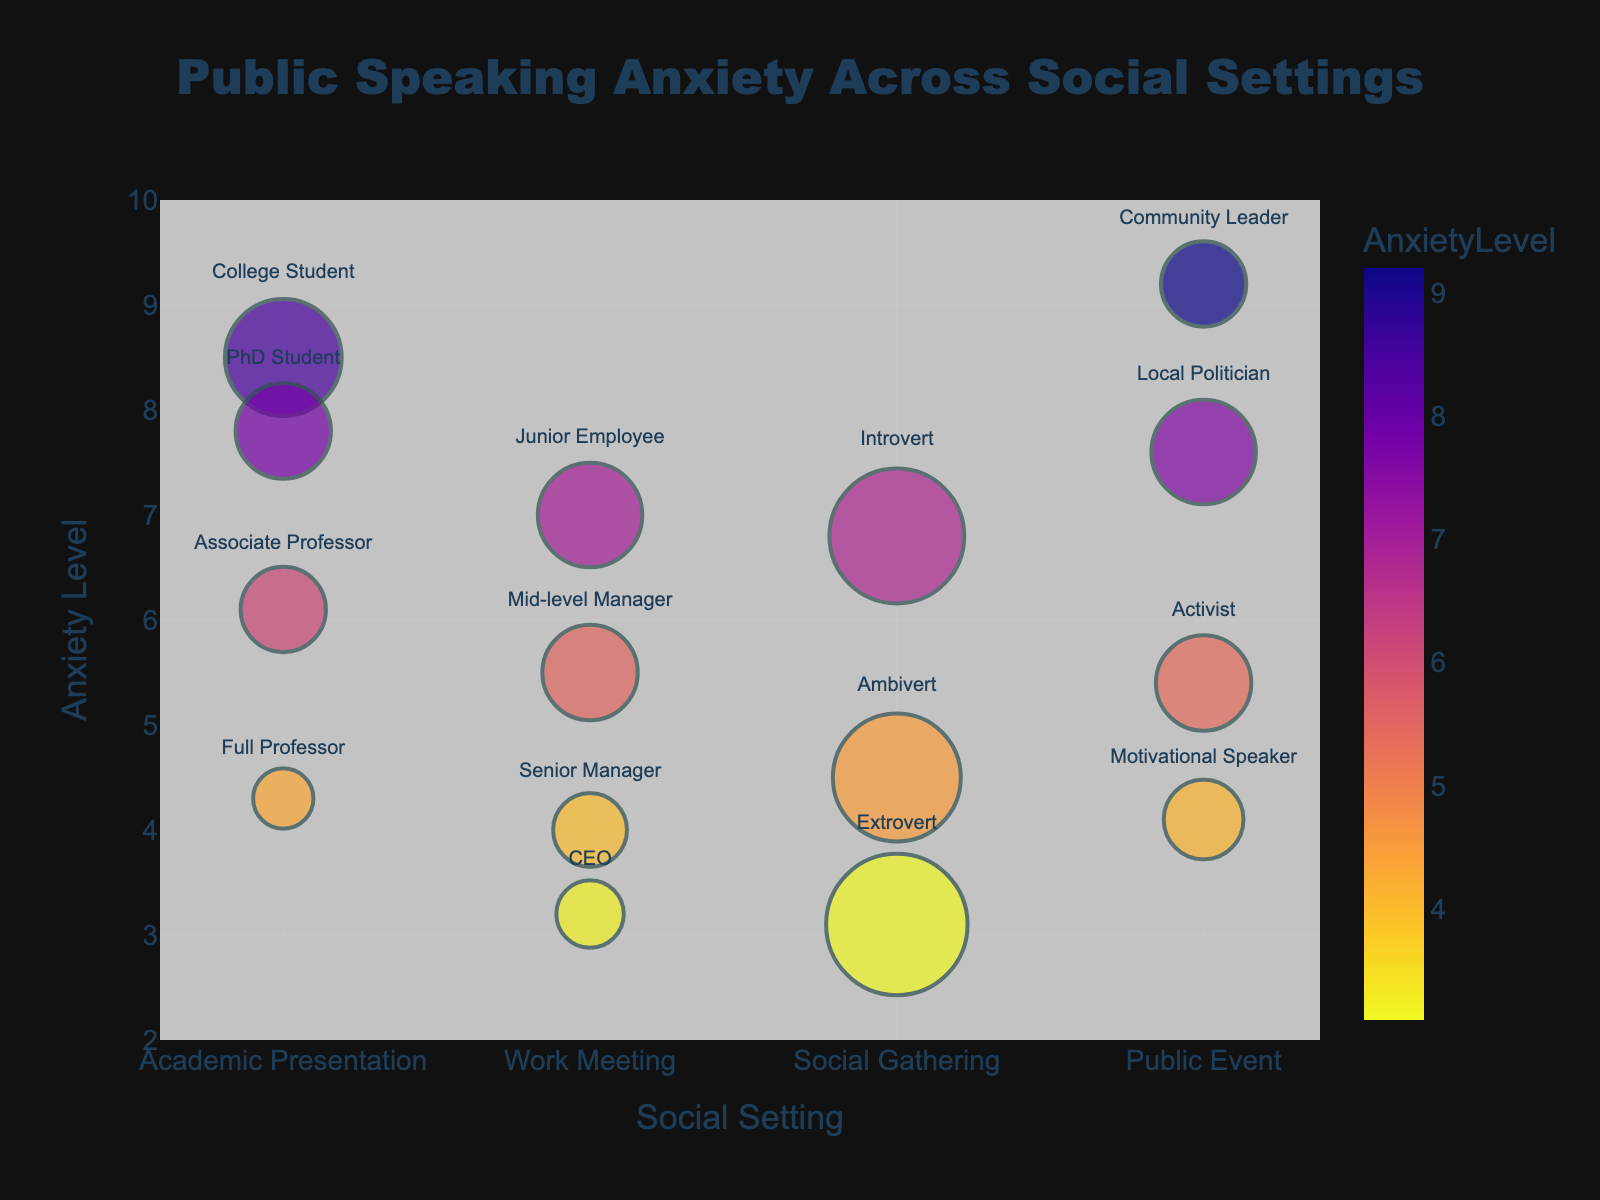What's the title of the chart? The title of a chart is usually located at the top center of the figure. It provides a quick overview of what the chart represents. In this case, the title is stated to be "Public Speaking Anxiety Across Social Settings".
Answer: Public Speaking Anxiety Across Social Settings Which social setting has the highest average anxiety level? To find the social setting with the highest average anxiety level, look at the y-axis values that are highest for each social setting. The Academic Presentations have a highest value of 8.5 (College Student), while Work Meetings highest is 7.0 (Junior Employee), Social Gatherings is 6.8 (Introvert), and Public Events is 9.2 (Community Leader).
Answer: Public Event How many social settings are represented in the chart? Count the distinct categories along the x-axis of the chart, representing different social settings. These are "Academic Presentation", "Work Meeting", "Social Gathering", and "Public Event". There are four categories.
Answer: 4 Which speaker identity has the lowest anxiety level in the chart? To find the speaker with the lowest anxiety level, look at the data points with the smallest y-axis values. The data point with the lowest y-axis value represents "CEO" in Work Meeting with an anxiety level of 3.2.
Answer: CEO Compare the anxiety levels of Introverts and Extroverts in social gatherings. Which group shows higher anxiety and by how much? Look at the data points for Introverts and Extroverts within "Social Gathering". The Introvert's anxiety level is 6.8, and the Extrovert's anxiety level is 3.1. To find the difference, subtract 3.1 from 6.8, which gives 3.7. So, Introverts show higher anxiety by 3.7 points.
Answer: Introverts, 3.7 What is the total frequency of speakers in the "Academic Presentations" setting? To determine the total frequency for "Academic Presentations", sum the frequencies of all data points within this category. The frequencies are 15 (College Student), 10 (PhD Student), 8 (Associate Professor), and 4 (Full Professor). The total is 15 + 10 + 8 + 4 = 37.
Answer: 37 Which social setting has the highest variability in anxiety levels? Examine the range (difference between highest and lowest values) of anxiety levels for each social setting. Academic Presentation ranges from 8.5 to 4.3, Work Meeting from 7.0 to 3.2, Social Gathering from 6.8 to 3.1, and Public Event from 9.2 to 4.1. The largest range is in Public Event which ranges from 9.2 to 4.1, a difference of 5.1.
Answer: Public Event What is the average anxiety level for the "Work Meeting" social setting? To calculate the average anxiety level for "Work Meeting", sum the anxiety levels for all relevant data points and divide by the number of points. The anxiety levels are 7.0, 5.5, 4.0, and 3.2. The sum is 7.0 + 5.5 + 4.0 + 3.2 = 19.7 and there are 4 data points. The average is 19.7 / 4 = 4.925.
Answer: 4.925 